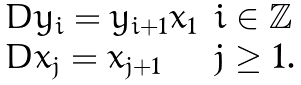Convert formula to latex. <formula><loc_0><loc_0><loc_500><loc_500>\begin{array} { l l } D y _ { i } = y _ { i + 1 } x _ { 1 } & i \in \mathbb { Z } \\ D x _ { j } = x _ { j + 1 } & j \geq 1 . \end{array}</formula> 